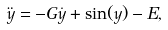Convert formula to latex. <formula><loc_0><loc_0><loc_500><loc_500>\ddot { y } = - G \dot { y } + \sin ( y ) - E ,</formula> 